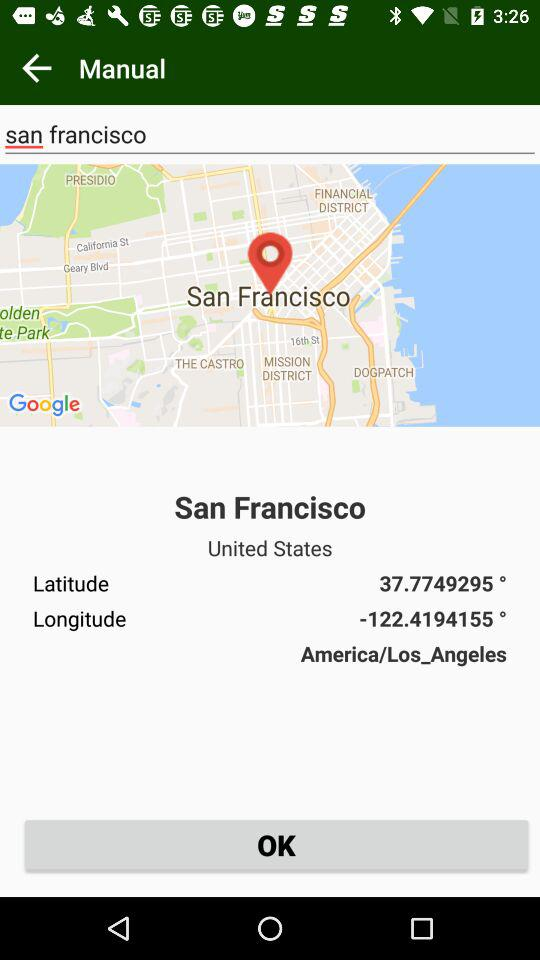What's the longitude of San Francisco? The longitude of San Francisco is -122.4194155 °. 